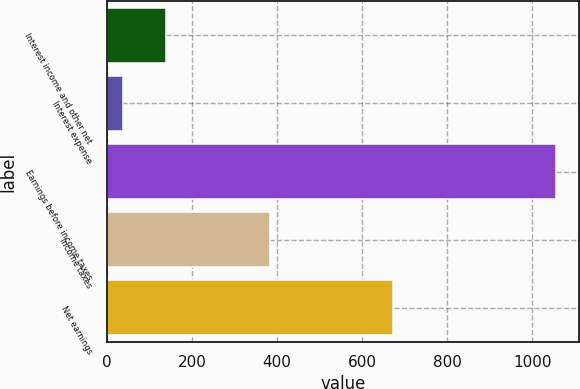Convert chart to OTSL. <chart><loc_0><loc_0><loc_500><loc_500><bar_chart><fcel>Interest income and other net<fcel>Interest expense<fcel>Earnings before income taxes<fcel>Income taxes<fcel>Net earnings<nl><fcel>139.83<fcel>38<fcel>1056.3<fcel>383.7<fcel>672.6<nl></chart> 